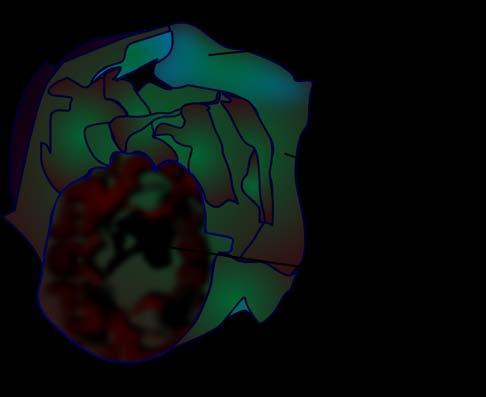does the cyst wall show presence of loculi containing gelatinous mucoid material?
Answer the question using a single word or phrase. Yes 